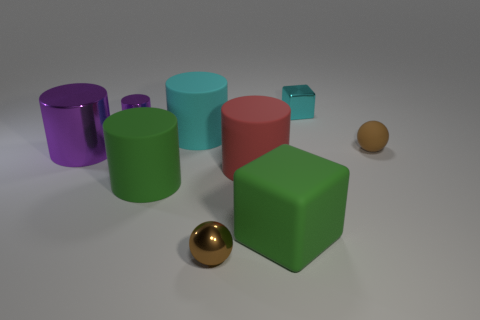There is a large object that is the same color as the shiny cube; what shape is it?
Your answer should be compact. Cylinder. Is there anything else that is the same color as the tiny cube?
Give a very brief answer. Yes. What size is the other sphere that is the same color as the tiny matte ball?
Provide a succinct answer. Small. Is the color of the matte object right of the tiny shiny cube the same as the metallic ball?
Provide a short and direct response. Yes. What number of big shiny cylinders are the same color as the tiny cylinder?
Make the answer very short. 1. There is a cube in front of the cyan block; what color is it?
Give a very brief answer. Green. Is the shape of the small brown rubber object the same as the tiny brown metallic object?
Keep it short and to the point. Yes. There is a rubber thing that is in front of the red rubber cylinder and left of the metallic ball; what color is it?
Give a very brief answer. Green. There is a brown sphere to the right of the large red object; does it have the same size as the matte block in front of the large purple shiny cylinder?
Provide a short and direct response. No. What number of objects are either tiny spheres to the left of the big red object or tiny cyan cylinders?
Ensure brevity in your answer.  1. 